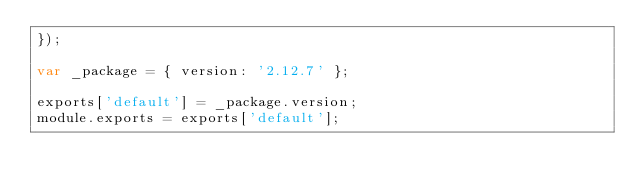<code> <loc_0><loc_0><loc_500><loc_500><_JavaScript_>});

var _package = { version: '2.12.7' };

exports['default'] = _package.version;
module.exports = exports['default'];</code> 